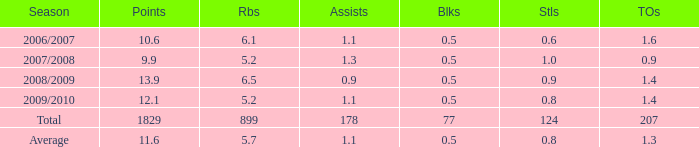What is the maximum rebounds when there are 0.9 steals and fewer than 1.4 turnovers? None. 